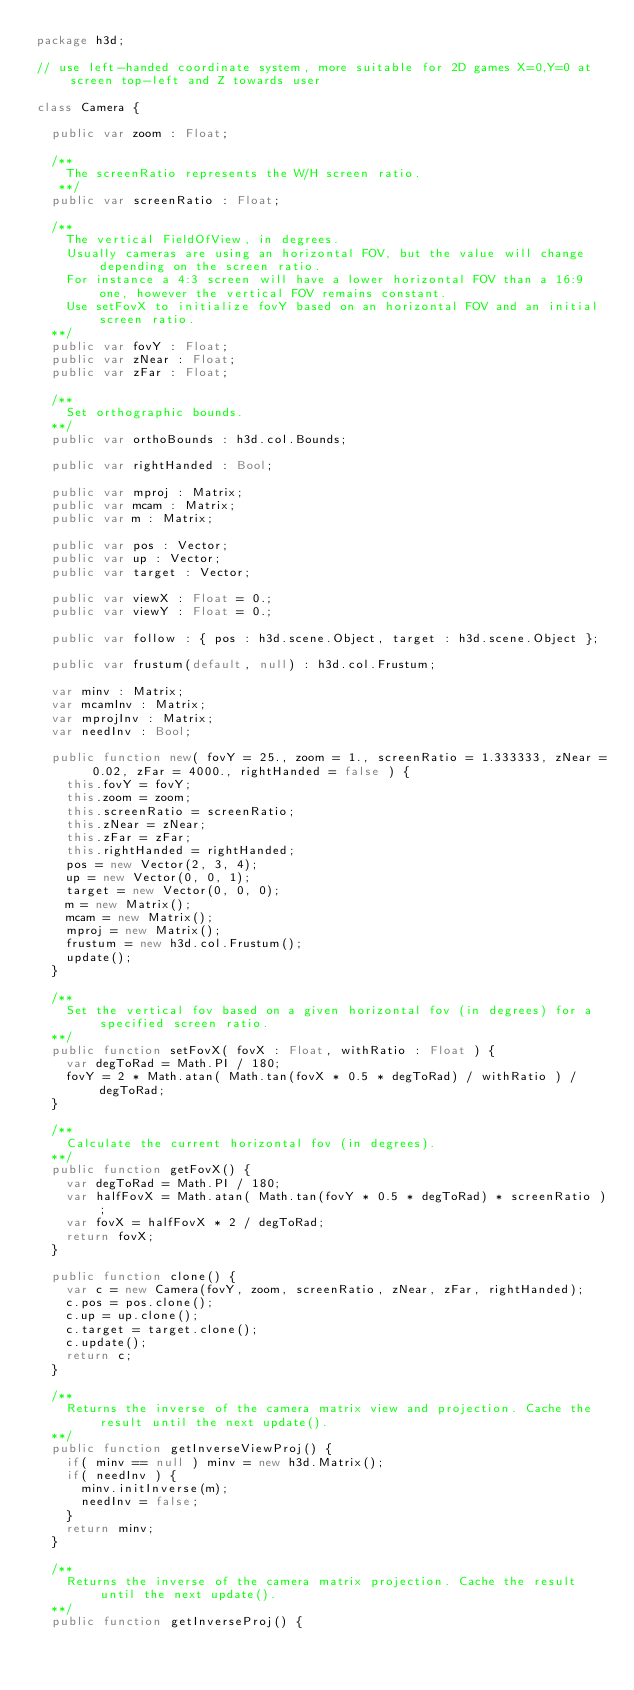Convert code to text. <code><loc_0><loc_0><loc_500><loc_500><_Haxe_>package h3d;

// use left-handed coordinate system, more suitable for 2D games X=0,Y=0 at screen top-left and Z towards user

class Camera {

	public var zoom : Float;

	/**
		The screenRatio represents the W/H screen ratio.
	 **/
	public var screenRatio : Float;

	/**
		The vertical FieldOfView, in degrees.
		Usually cameras are using an horizontal FOV, but the value will change depending on the screen ratio.
		For instance a 4:3 screen will have a lower horizontal FOV than a 16:9 one, however the vertical FOV remains constant.
		Use setFovX to initialize fovY based on an horizontal FOV and an initial screen ratio.
	**/
	public var fovY : Float;
	public var zNear : Float;
	public var zFar : Float;

	/**
		Set orthographic bounds.
	**/
	public var orthoBounds : h3d.col.Bounds;

	public var rightHanded : Bool;

	public var mproj : Matrix;
	public var mcam : Matrix;
	public var m : Matrix;

	public var pos : Vector;
	public var up : Vector;
	public var target : Vector;

	public var viewX : Float = 0.;
	public var viewY : Float = 0.;

	public var follow : { pos : h3d.scene.Object, target : h3d.scene.Object };

	public var frustum(default, null) : h3d.col.Frustum;

	var minv : Matrix;
	var mcamInv : Matrix;
	var mprojInv : Matrix;
	var needInv : Bool;

	public function new( fovY = 25., zoom = 1., screenRatio = 1.333333, zNear = 0.02, zFar = 4000., rightHanded = false ) {
		this.fovY = fovY;
		this.zoom = zoom;
		this.screenRatio = screenRatio;
		this.zNear = zNear;
		this.zFar = zFar;
		this.rightHanded = rightHanded;
		pos = new Vector(2, 3, 4);
		up = new Vector(0, 0, 1);
		target = new Vector(0, 0, 0);
		m = new Matrix();
		mcam = new Matrix();
		mproj = new Matrix();
		frustum = new h3d.col.Frustum();
		update();
	}

	/**
		Set the vertical fov based on a given horizontal fov (in degrees) for a specified screen ratio.
	**/
	public function setFovX( fovX : Float, withRatio : Float ) {
		var degToRad = Math.PI / 180;
		fovY = 2 * Math.atan( Math.tan(fovX * 0.5 * degToRad) / withRatio ) / degToRad;
	}

	/**
		Calculate the current horizontal fov (in degrees).
	**/
	public function getFovX() {
		var degToRad = Math.PI / 180;
		var halfFovX = Math.atan( Math.tan(fovY * 0.5 * degToRad) * screenRatio );
		var fovX = halfFovX * 2 / degToRad;
		return fovX;
	}

	public function clone() {
		var c = new Camera(fovY, zoom, screenRatio, zNear, zFar, rightHanded);
		c.pos = pos.clone();
		c.up = up.clone();
		c.target = target.clone();
		c.update();
		return c;
	}

	/**
		Returns the inverse of the camera matrix view and projection. Cache the result until the next update().
	**/
	public function getInverseViewProj() {
		if( minv == null ) minv = new h3d.Matrix();
		if( needInv ) {
			minv.initInverse(m);
			needInv = false;
		}
		return minv;
	}

	/**
		Returns the inverse of the camera matrix projection. Cache the result until the next update().
	**/
	public function getInverseProj() {</code> 